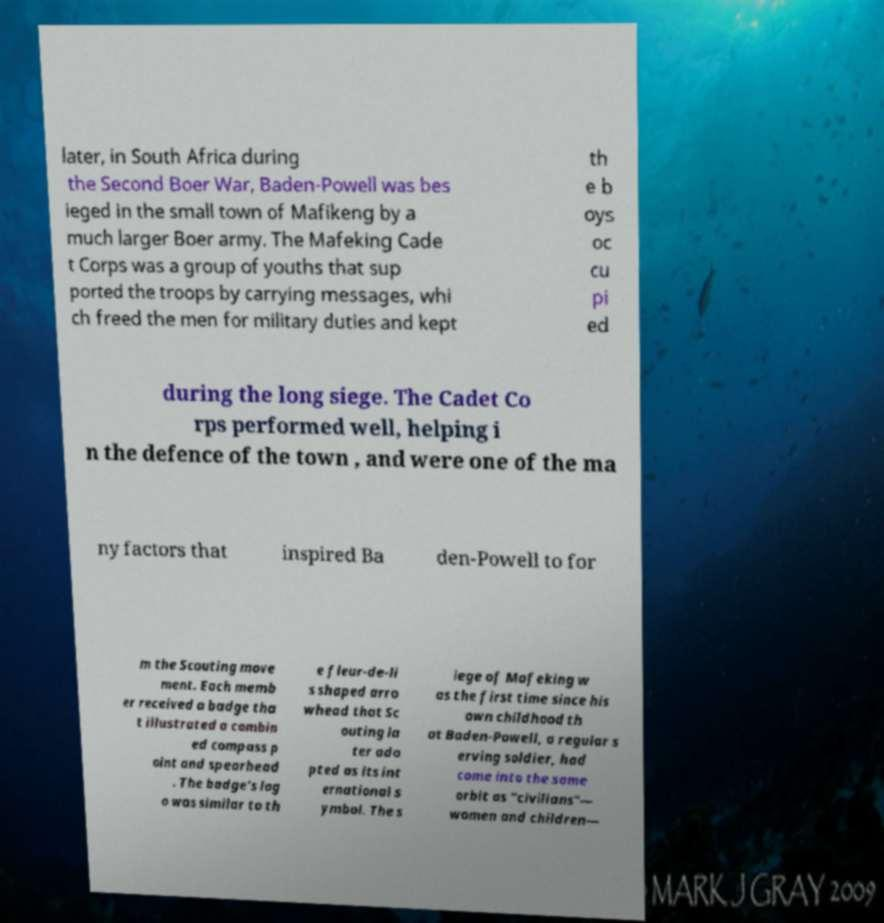For documentation purposes, I need the text within this image transcribed. Could you provide that? later, in South Africa during the Second Boer War, Baden-Powell was bes ieged in the small town of Mafikeng by a much larger Boer army. The Mafeking Cade t Corps was a group of youths that sup ported the troops by carrying messages, whi ch freed the men for military duties and kept th e b oys oc cu pi ed during the long siege. The Cadet Co rps performed well, helping i n the defence of the town , and were one of the ma ny factors that inspired Ba den-Powell to for m the Scouting move ment. Each memb er received a badge tha t illustrated a combin ed compass p oint and spearhead . The badge's log o was similar to th e fleur-de-li s shaped arro whead that Sc outing la ter ado pted as its int ernational s ymbol. The s iege of Mafeking w as the first time since his own childhood th at Baden-Powell, a regular s erving soldier, had come into the same orbit as "civilians"— women and children— 